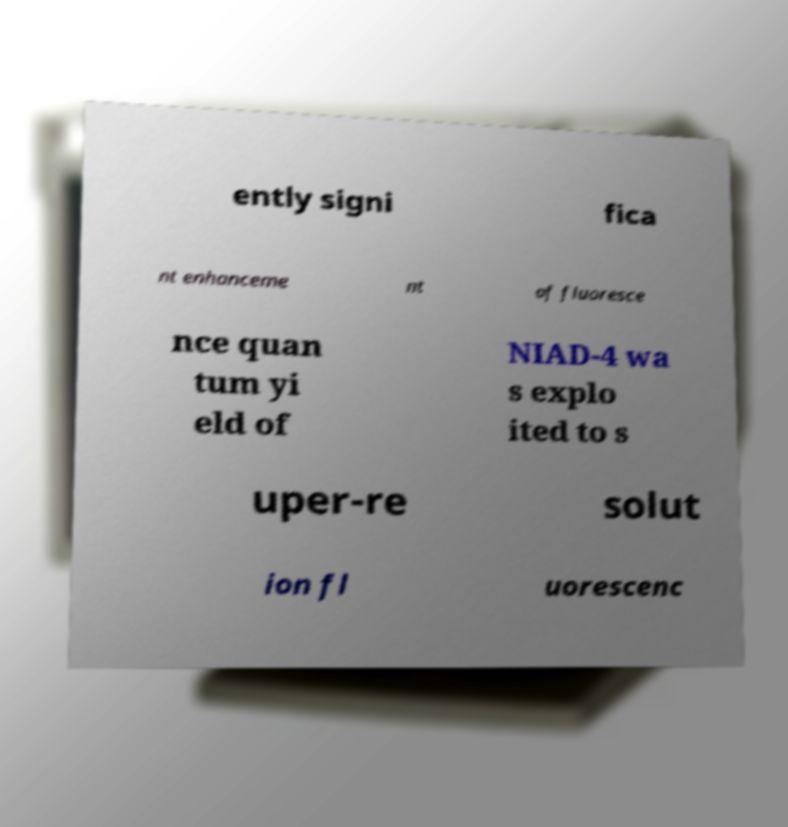Can you read and provide the text displayed in the image?This photo seems to have some interesting text. Can you extract and type it out for me? ently signi fica nt enhanceme nt of fluoresce nce quan tum yi eld of NIAD-4 wa s explo ited to s uper-re solut ion fl uorescenc 